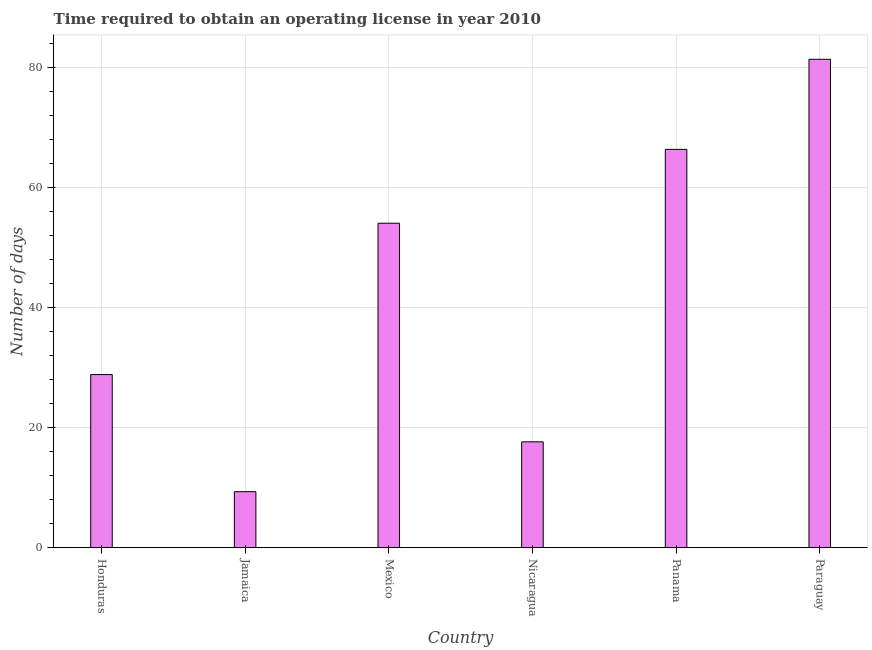Does the graph contain any zero values?
Offer a terse response. No. Does the graph contain grids?
Provide a succinct answer. Yes. What is the title of the graph?
Your answer should be very brief. Time required to obtain an operating license in year 2010. What is the label or title of the Y-axis?
Provide a short and direct response. Number of days. Across all countries, what is the maximum number of days to obtain operating license?
Offer a terse response. 81.3. In which country was the number of days to obtain operating license maximum?
Your answer should be very brief. Paraguay. In which country was the number of days to obtain operating license minimum?
Ensure brevity in your answer.  Jamaica. What is the sum of the number of days to obtain operating license?
Make the answer very short. 257.3. What is the difference between the number of days to obtain operating license in Mexico and Nicaragua?
Offer a terse response. 36.4. What is the average number of days to obtain operating license per country?
Your answer should be compact. 42.88. What is the median number of days to obtain operating license?
Make the answer very short. 41.4. In how many countries, is the number of days to obtain operating license greater than 40 days?
Offer a very short reply. 3. What is the ratio of the number of days to obtain operating license in Jamaica to that in Panama?
Your response must be concise. 0.14. Is the number of days to obtain operating license in Honduras less than that in Nicaragua?
Keep it short and to the point. No. What is the difference between the highest and the second highest number of days to obtain operating license?
Offer a very short reply. 15. How many bars are there?
Ensure brevity in your answer.  6. Are all the bars in the graph horizontal?
Offer a terse response. No. How many countries are there in the graph?
Make the answer very short. 6. What is the difference between two consecutive major ticks on the Y-axis?
Provide a short and direct response. 20. Are the values on the major ticks of Y-axis written in scientific E-notation?
Keep it short and to the point. No. What is the Number of days of Honduras?
Your answer should be compact. 28.8. What is the Number of days in Jamaica?
Your response must be concise. 9.3. What is the Number of days in Mexico?
Give a very brief answer. 54. What is the Number of days in Panama?
Offer a terse response. 66.3. What is the Number of days of Paraguay?
Give a very brief answer. 81.3. What is the difference between the Number of days in Honduras and Mexico?
Give a very brief answer. -25.2. What is the difference between the Number of days in Honduras and Panama?
Your response must be concise. -37.5. What is the difference between the Number of days in Honduras and Paraguay?
Give a very brief answer. -52.5. What is the difference between the Number of days in Jamaica and Mexico?
Your answer should be very brief. -44.7. What is the difference between the Number of days in Jamaica and Panama?
Make the answer very short. -57. What is the difference between the Number of days in Jamaica and Paraguay?
Your answer should be compact. -72. What is the difference between the Number of days in Mexico and Nicaragua?
Give a very brief answer. 36.4. What is the difference between the Number of days in Mexico and Panama?
Offer a terse response. -12.3. What is the difference between the Number of days in Mexico and Paraguay?
Give a very brief answer. -27.3. What is the difference between the Number of days in Nicaragua and Panama?
Give a very brief answer. -48.7. What is the difference between the Number of days in Nicaragua and Paraguay?
Provide a succinct answer. -63.7. What is the ratio of the Number of days in Honduras to that in Jamaica?
Give a very brief answer. 3.1. What is the ratio of the Number of days in Honduras to that in Mexico?
Ensure brevity in your answer.  0.53. What is the ratio of the Number of days in Honduras to that in Nicaragua?
Keep it short and to the point. 1.64. What is the ratio of the Number of days in Honduras to that in Panama?
Provide a short and direct response. 0.43. What is the ratio of the Number of days in Honduras to that in Paraguay?
Your answer should be compact. 0.35. What is the ratio of the Number of days in Jamaica to that in Mexico?
Offer a terse response. 0.17. What is the ratio of the Number of days in Jamaica to that in Nicaragua?
Give a very brief answer. 0.53. What is the ratio of the Number of days in Jamaica to that in Panama?
Your response must be concise. 0.14. What is the ratio of the Number of days in Jamaica to that in Paraguay?
Keep it short and to the point. 0.11. What is the ratio of the Number of days in Mexico to that in Nicaragua?
Give a very brief answer. 3.07. What is the ratio of the Number of days in Mexico to that in Panama?
Make the answer very short. 0.81. What is the ratio of the Number of days in Mexico to that in Paraguay?
Make the answer very short. 0.66. What is the ratio of the Number of days in Nicaragua to that in Panama?
Your answer should be compact. 0.27. What is the ratio of the Number of days in Nicaragua to that in Paraguay?
Keep it short and to the point. 0.22. What is the ratio of the Number of days in Panama to that in Paraguay?
Ensure brevity in your answer.  0.81. 